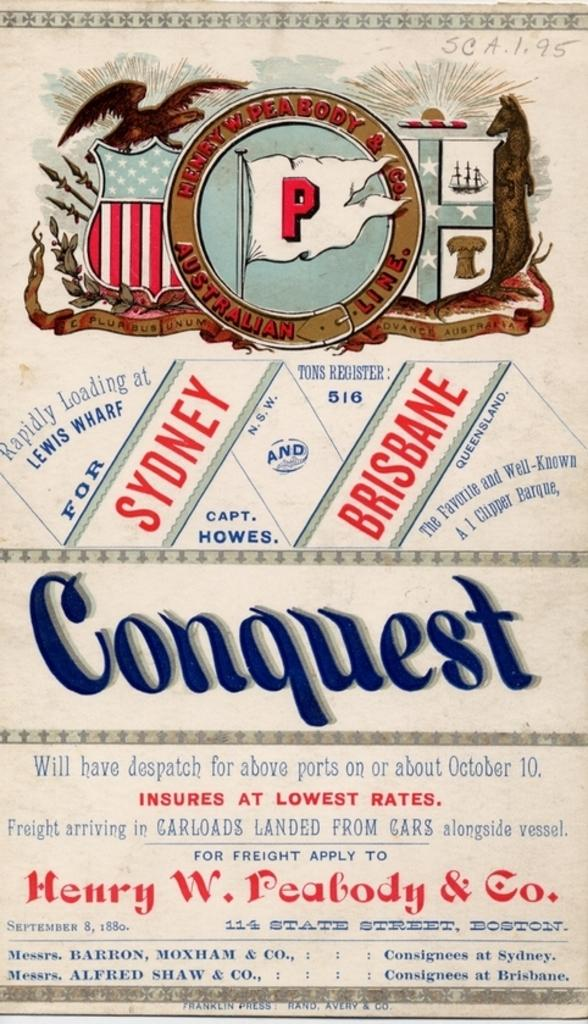Provide a one-sentence caption for the provided image. An advertisement for Henry W. Peabody & Co. in predominantly red, white and blue. 